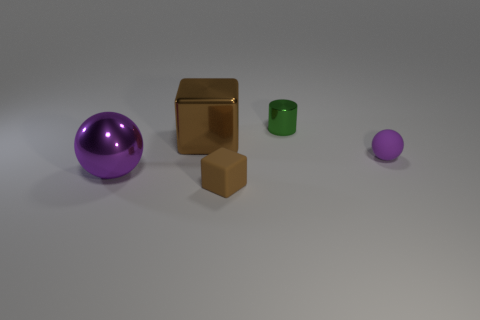Add 2 large purple things. How many objects exist? 7 Subtract all balls. How many objects are left? 3 Subtract 0 red cubes. How many objects are left? 5 Subtract all tiny blue matte cubes. Subtract all tiny metallic cylinders. How many objects are left? 4 Add 2 green shiny objects. How many green shiny objects are left? 3 Add 1 large green metallic spheres. How many large green metallic spheres exist? 1 